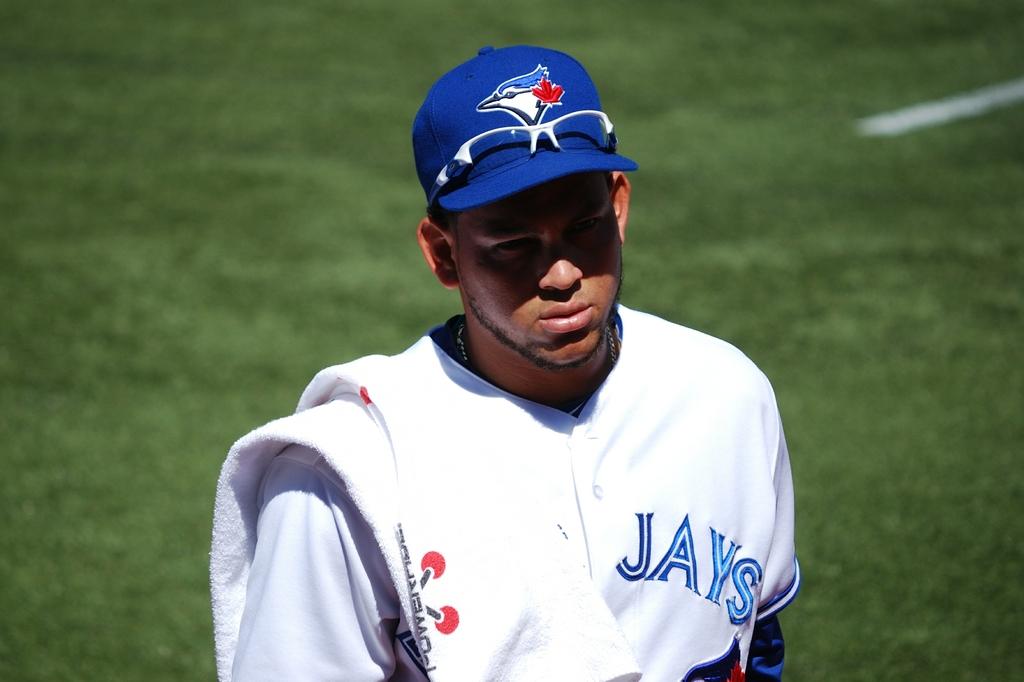What does it say on the front of the jersey?
Provide a succinct answer. Jays. 